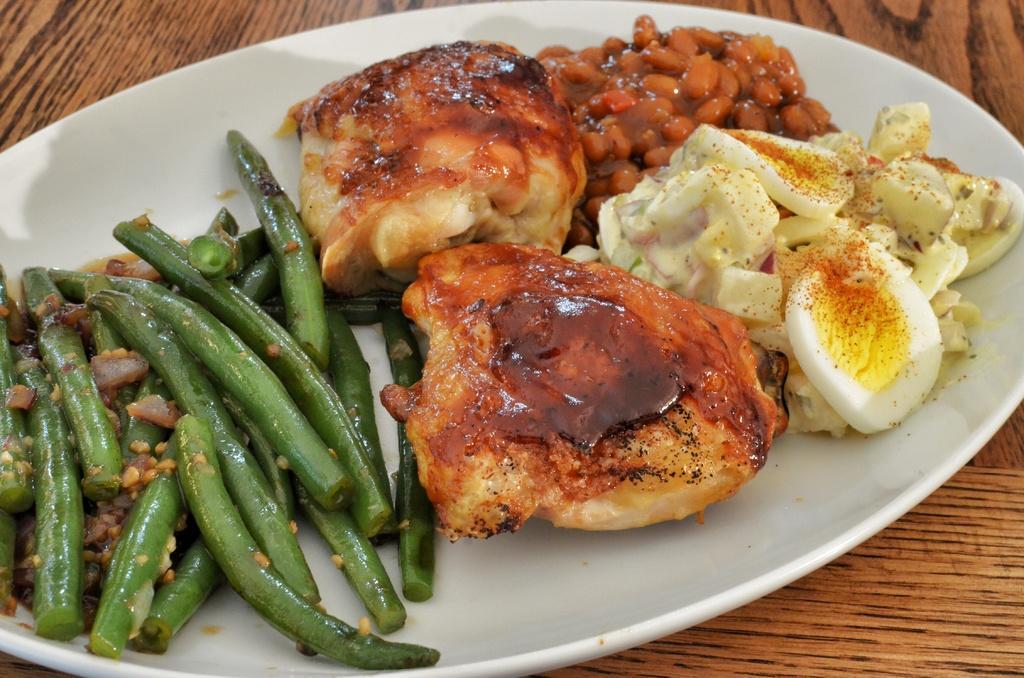Can you describe this image briefly? In this image there is a table, on the table there is a plate and on the plate there is food. 